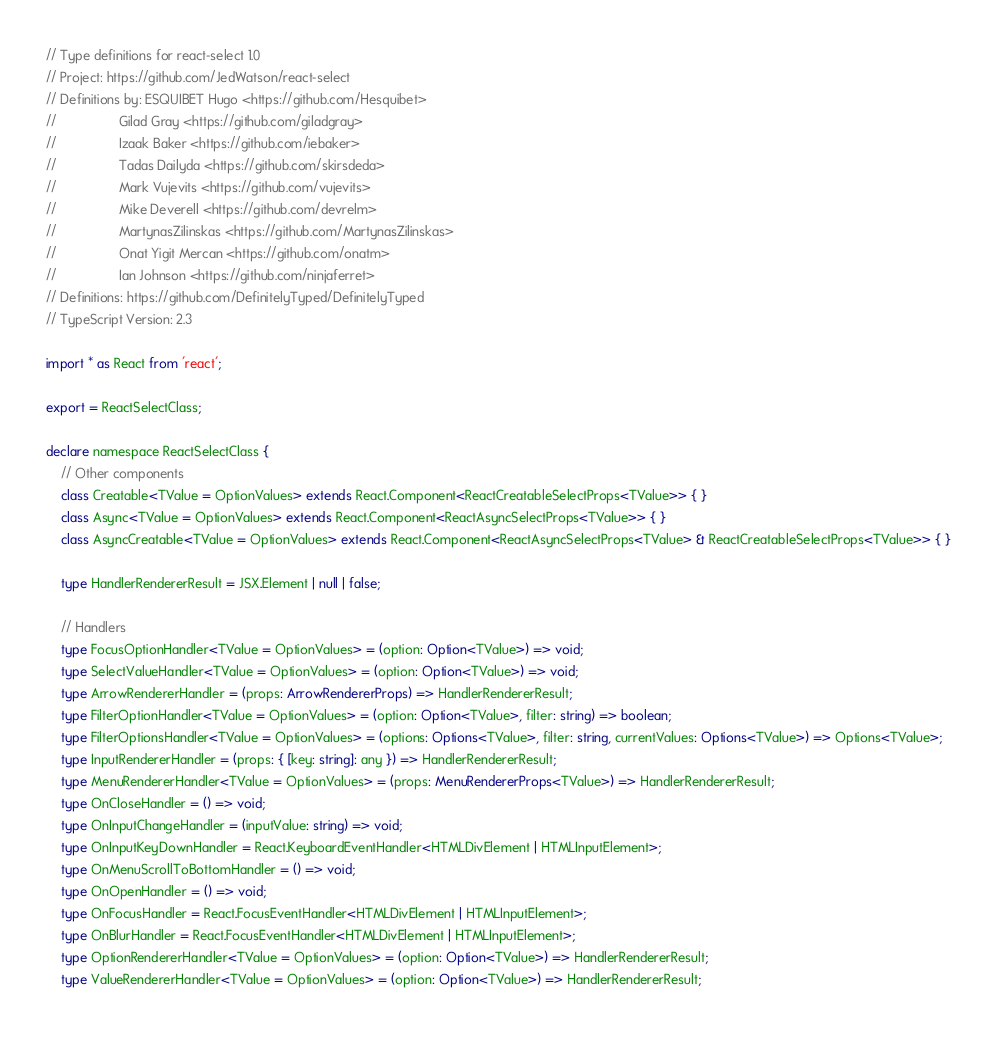<code> <loc_0><loc_0><loc_500><loc_500><_TypeScript_>// Type definitions for react-select 1.0
// Project: https://github.com/JedWatson/react-select
// Definitions by: ESQUIBET Hugo <https://github.com/Hesquibet>
//                 Gilad Gray <https://github.com/giladgray>
//                 Izaak Baker <https://github.com/iebaker>
//                 Tadas Dailyda <https://github.com/skirsdeda>
//                 Mark Vujevits <https://github.com/vujevits>
//                 Mike Deverell <https://github.com/devrelm>
//                 MartynasZilinskas <https://github.com/MartynasZilinskas>
//                 Onat Yigit Mercan <https://github.com/onatm>
//                 Ian Johnson <https://github.com/ninjaferret>
// Definitions: https://github.com/DefinitelyTyped/DefinitelyTyped
// TypeScript Version: 2.3

import * as React from 'react';

export = ReactSelectClass;

declare namespace ReactSelectClass {
    // Other components
    class Creatable<TValue = OptionValues> extends React.Component<ReactCreatableSelectProps<TValue>> { }
    class Async<TValue = OptionValues> extends React.Component<ReactAsyncSelectProps<TValue>> { }
    class AsyncCreatable<TValue = OptionValues> extends React.Component<ReactAsyncSelectProps<TValue> & ReactCreatableSelectProps<TValue>> { }

    type HandlerRendererResult = JSX.Element | null | false;

    // Handlers
    type FocusOptionHandler<TValue = OptionValues> = (option: Option<TValue>) => void;
    type SelectValueHandler<TValue = OptionValues> = (option: Option<TValue>) => void;
    type ArrowRendererHandler = (props: ArrowRendererProps) => HandlerRendererResult;
    type FilterOptionHandler<TValue = OptionValues> = (option: Option<TValue>, filter: string) => boolean;
    type FilterOptionsHandler<TValue = OptionValues> = (options: Options<TValue>, filter: string, currentValues: Options<TValue>) => Options<TValue>;
    type InputRendererHandler = (props: { [key: string]: any }) => HandlerRendererResult;
    type MenuRendererHandler<TValue = OptionValues> = (props: MenuRendererProps<TValue>) => HandlerRendererResult;
    type OnCloseHandler = () => void;
    type OnInputChangeHandler = (inputValue: string) => void;
    type OnInputKeyDownHandler = React.KeyboardEventHandler<HTMLDivElement | HTMLInputElement>;
    type OnMenuScrollToBottomHandler = () => void;
    type OnOpenHandler = () => void;
    type OnFocusHandler = React.FocusEventHandler<HTMLDivElement | HTMLInputElement>;
    type OnBlurHandler = React.FocusEventHandler<HTMLDivElement | HTMLInputElement>;
    type OptionRendererHandler<TValue = OptionValues> = (option: Option<TValue>) => HandlerRendererResult;
    type ValueRendererHandler<TValue = OptionValues> = (option: Option<TValue>) => HandlerRendererResult;</code> 